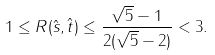Convert formula to latex. <formula><loc_0><loc_0><loc_500><loc_500>1 \leq R ( \hat { s } , \hat { t } ) \leq \frac { \sqrt { 5 } - 1 } { 2 ( \sqrt { 5 } - 2 ) } < 3 . \\</formula> 